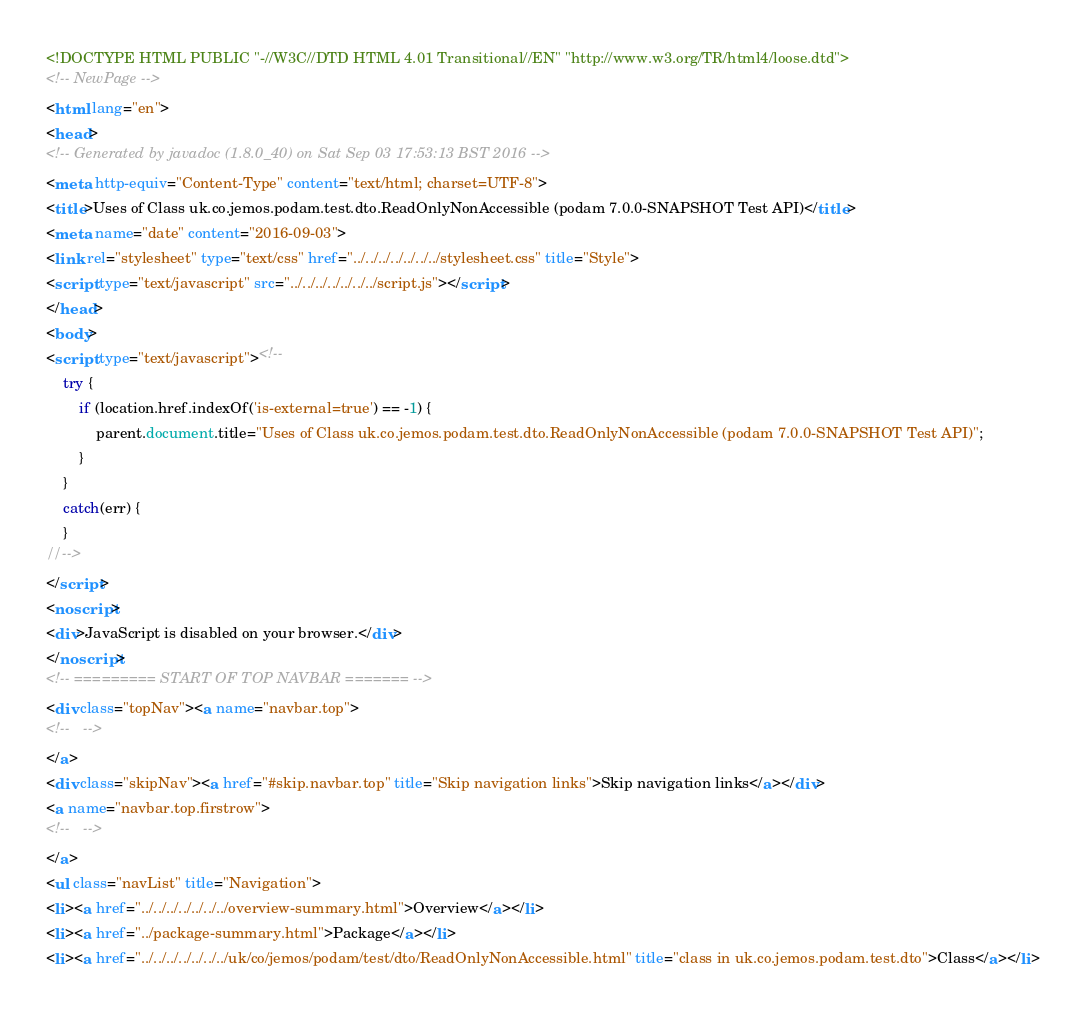Convert code to text. <code><loc_0><loc_0><loc_500><loc_500><_HTML_><!DOCTYPE HTML PUBLIC "-//W3C//DTD HTML 4.01 Transitional//EN" "http://www.w3.org/TR/html4/loose.dtd">
<!-- NewPage -->
<html lang="en">
<head>
<!-- Generated by javadoc (1.8.0_40) on Sat Sep 03 17:53:13 BST 2016 -->
<meta http-equiv="Content-Type" content="text/html; charset=UTF-8">
<title>Uses of Class uk.co.jemos.podam.test.dto.ReadOnlyNonAccessible (podam 7.0.0-SNAPSHOT Test API)</title>
<meta name="date" content="2016-09-03">
<link rel="stylesheet" type="text/css" href="../../../../../../../stylesheet.css" title="Style">
<script type="text/javascript" src="../../../../../../../script.js"></script>
</head>
<body>
<script type="text/javascript"><!--
    try {
        if (location.href.indexOf('is-external=true') == -1) {
            parent.document.title="Uses of Class uk.co.jemos.podam.test.dto.ReadOnlyNonAccessible (podam 7.0.0-SNAPSHOT Test API)";
        }
    }
    catch(err) {
    }
//-->
</script>
<noscript>
<div>JavaScript is disabled on your browser.</div>
</noscript>
<!-- ========= START OF TOP NAVBAR ======= -->
<div class="topNav"><a name="navbar.top">
<!--   -->
</a>
<div class="skipNav"><a href="#skip.navbar.top" title="Skip navigation links">Skip navigation links</a></div>
<a name="navbar.top.firstrow">
<!--   -->
</a>
<ul class="navList" title="Navigation">
<li><a href="../../../../../../../overview-summary.html">Overview</a></li>
<li><a href="../package-summary.html">Package</a></li>
<li><a href="../../../../../../../uk/co/jemos/podam/test/dto/ReadOnlyNonAccessible.html" title="class in uk.co.jemos.podam.test.dto">Class</a></li></code> 